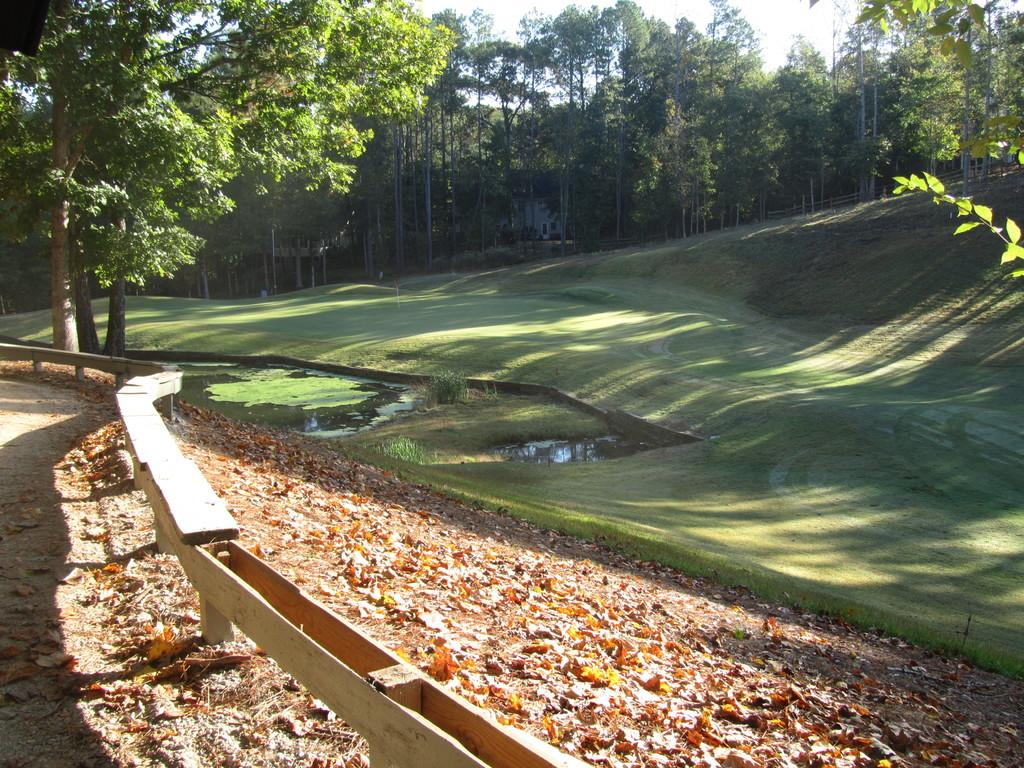What type of vegetation can be seen in the image? There are trees and grass in the image. What body of water is present in the image? There is a pond in the image. What is on the ground in the image? There are leaves on the ground in the image. What type of barrier is visible in the image? There is fencing in the image. What part of the natural environment is visible in the image? The sky is visible in the image. Where is the sofa located in the image? There is no sofa present in the image. What type of plants are growing on the ground in the image? The image does not show any specific plants growing on the ground; it only shows leaves. 